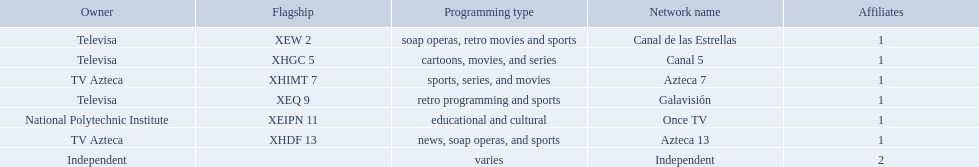Who are the owners of the stations listed here? Televisa, Televisa, TV Azteca, Televisa, National Polytechnic Institute, TV Azteca, Independent. What is the one station owned by national polytechnic institute? Once TV. What station shows cartoons? Canal 5. What station shows soap operas? Canal de las Estrellas. What station shows sports? Azteca 7. What television stations are in morelos? Canal de las Estrellas, Canal 5, Azteca 7, Galavisión, Once TV, Azteca 13, Independent. Of those which network is owned by national polytechnic institute? Once TV. 